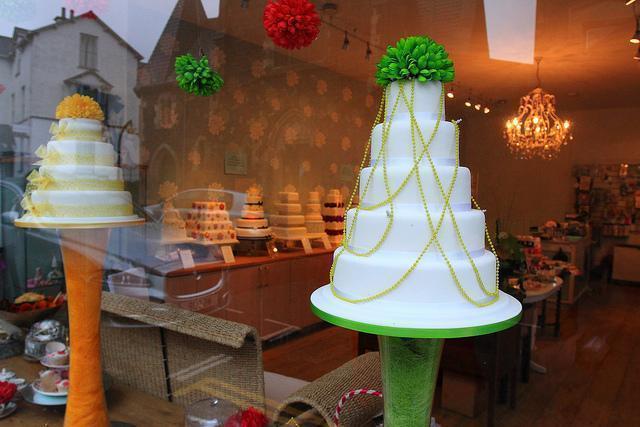What is inside of the large cake with green top and bottom?
Indicate the correct response by choosing from the four available options to answer the question.
Options: Caramel, nothing, chocolate, coconut. Nothing. 